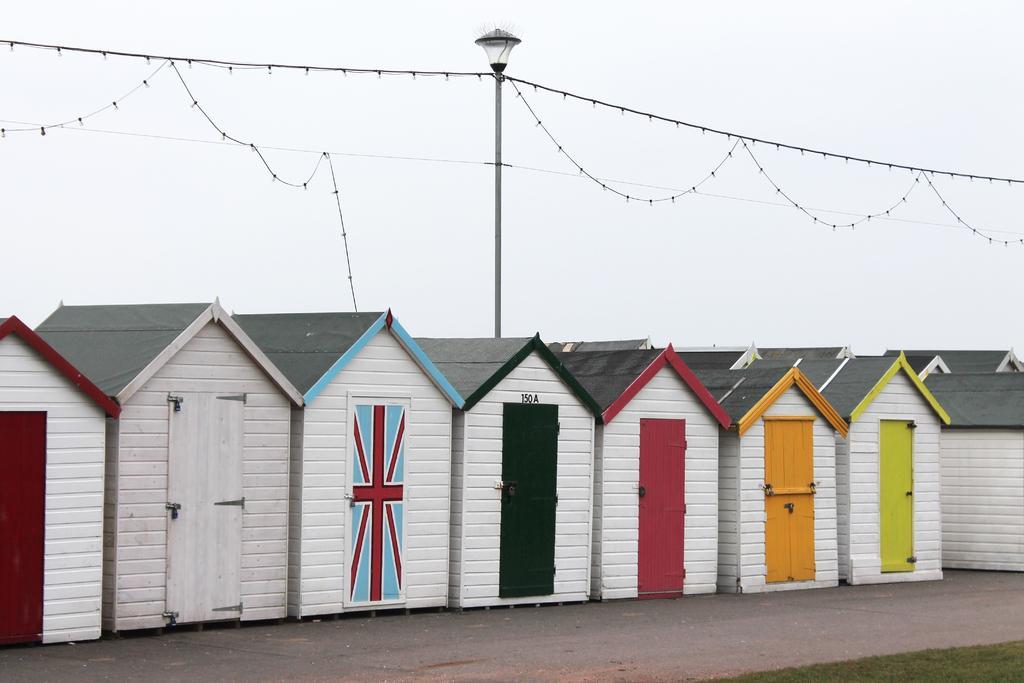Describe this image in one or two sentences. There are some wooden houses at the bottom of this image and there is a pole in the middle of this image. There are some lights hanging from this pole. There is a sky in the background. 